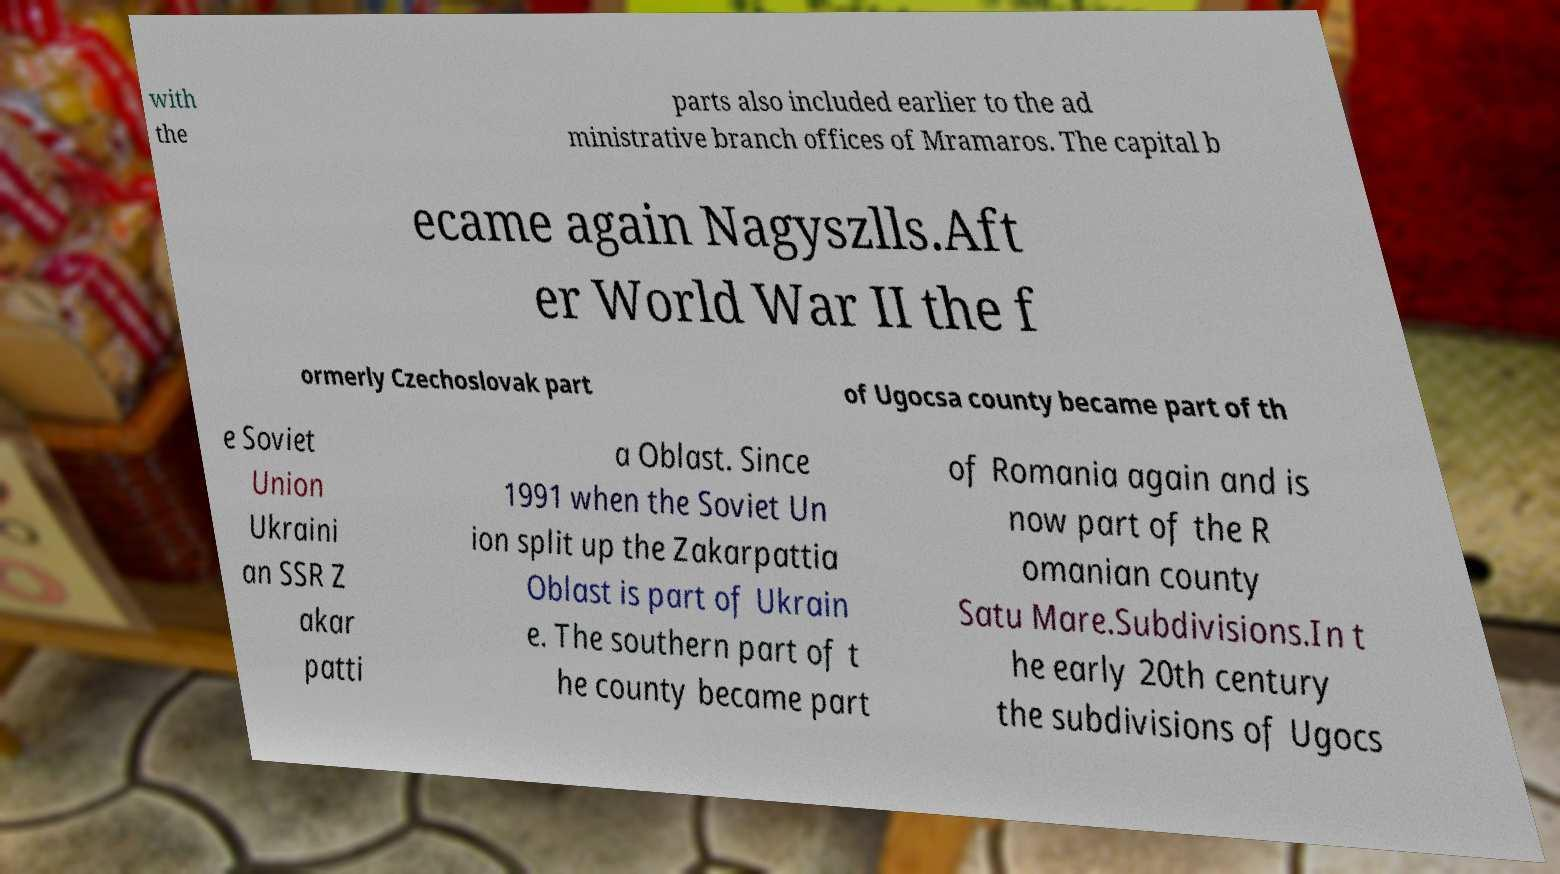Can you accurately transcribe the text from the provided image for me? with the parts also included earlier to the ad ministrative branch offices of Mramaros. The capital b ecame again Nagyszlls.Aft er World War II the f ormerly Czechoslovak part of Ugocsa county became part of th e Soviet Union Ukraini an SSR Z akar patti a Oblast. Since 1991 when the Soviet Un ion split up the Zakarpattia Oblast is part of Ukrain e. The southern part of t he county became part of Romania again and is now part of the R omanian county Satu Mare.Subdivisions.In t he early 20th century the subdivisions of Ugocs 